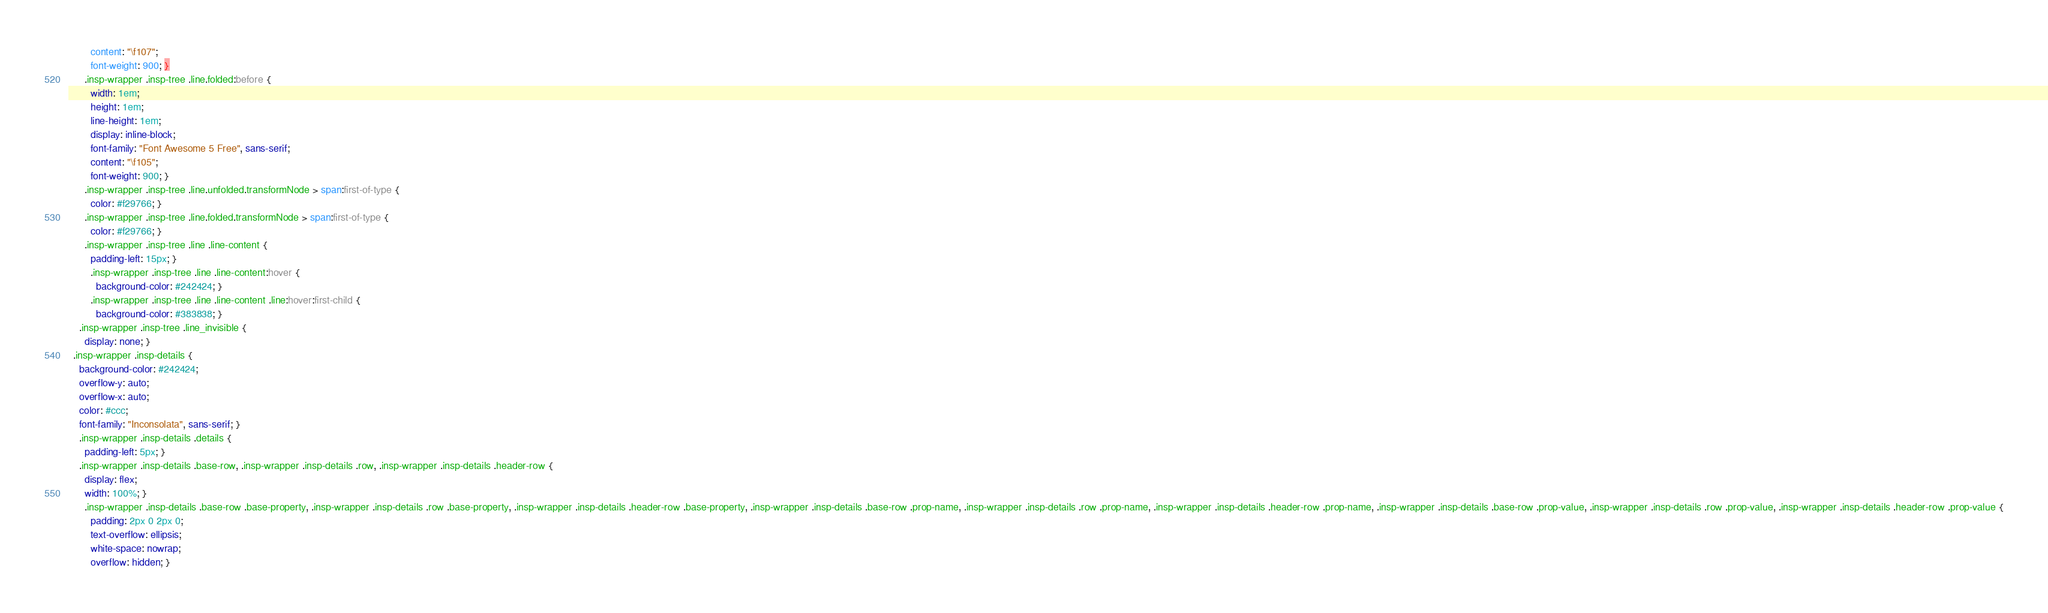Convert code to text. <code><loc_0><loc_0><loc_500><loc_500><_CSS_>        content: "\f107";
        font-weight: 900; }
      .insp-wrapper .insp-tree .line.folded:before {
        width: 1em;
        height: 1em;
        line-height: 1em;
        display: inline-block;
        font-family: "Font Awesome 5 Free", sans-serif;
        content: "\f105";
        font-weight: 900; }
      .insp-wrapper .insp-tree .line.unfolded.transformNode > span:first-of-type {
        color: #f29766; }
      .insp-wrapper .insp-tree .line.folded.transformNode > span:first-of-type {
        color: #f29766; }
      .insp-wrapper .insp-tree .line .line-content {
        padding-left: 15px; }
        .insp-wrapper .insp-tree .line .line-content:hover {
          background-color: #242424; }
        .insp-wrapper .insp-tree .line .line-content .line:hover:first-child {
          background-color: #383838; }
    .insp-wrapper .insp-tree .line_invisible {
      display: none; }
  .insp-wrapper .insp-details {
    background-color: #242424;
    overflow-y: auto;
    overflow-x: auto;
    color: #ccc;
    font-family: "Inconsolata", sans-serif; }
    .insp-wrapper .insp-details .details {
      padding-left: 5px; }
    .insp-wrapper .insp-details .base-row, .insp-wrapper .insp-details .row, .insp-wrapper .insp-details .header-row {
      display: flex;
      width: 100%; }
      .insp-wrapper .insp-details .base-row .base-property, .insp-wrapper .insp-details .row .base-property, .insp-wrapper .insp-details .header-row .base-property, .insp-wrapper .insp-details .base-row .prop-name, .insp-wrapper .insp-details .row .prop-name, .insp-wrapper .insp-details .header-row .prop-name, .insp-wrapper .insp-details .base-row .prop-value, .insp-wrapper .insp-details .row .prop-value, .insp-wrapper .insp-details .header-row .prop-value {
        padding: 2px 0 2px 0;
        text-overflow: ellipsis;
        white-space: nowrap;
        overflow: hidden; }</code> 